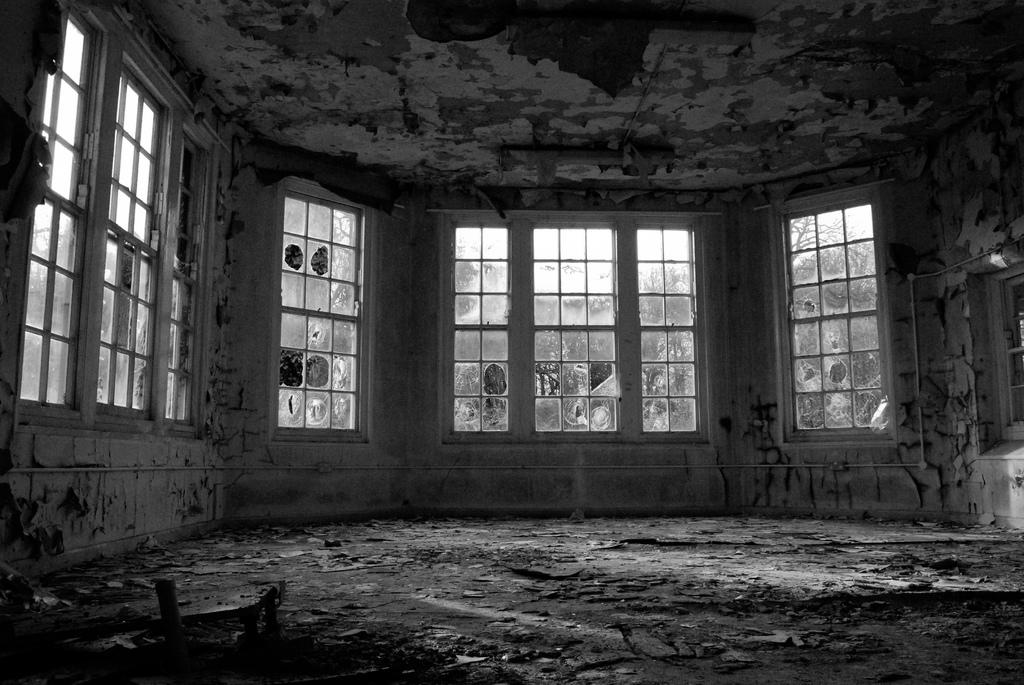What is located in the center of the image? There are windows in the center of the image. What can be inferred about the state of the house in the image? The house appears to be abandoned. What unit of measurement is used to calculate the profit of the house in the image? There is no information about the profit of the house in the image, so it is not possible to determine the unit of measurement used. Is there any indication of approval or disapproval of the house in the image? There is no indication of approval or disapproval of the house in the image. 